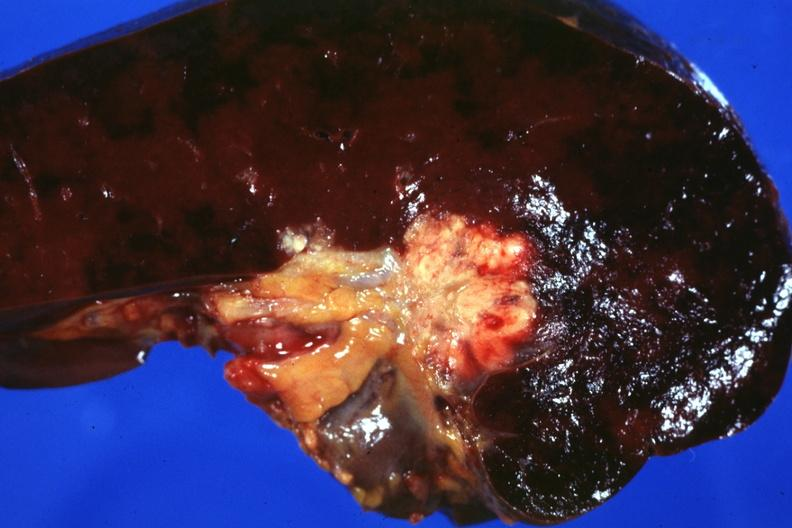do section of spleen through hilum show tumor mass in hilum slide and large metastatic nodules in spleen?
Answer the question using a single word or phrase. Yes 